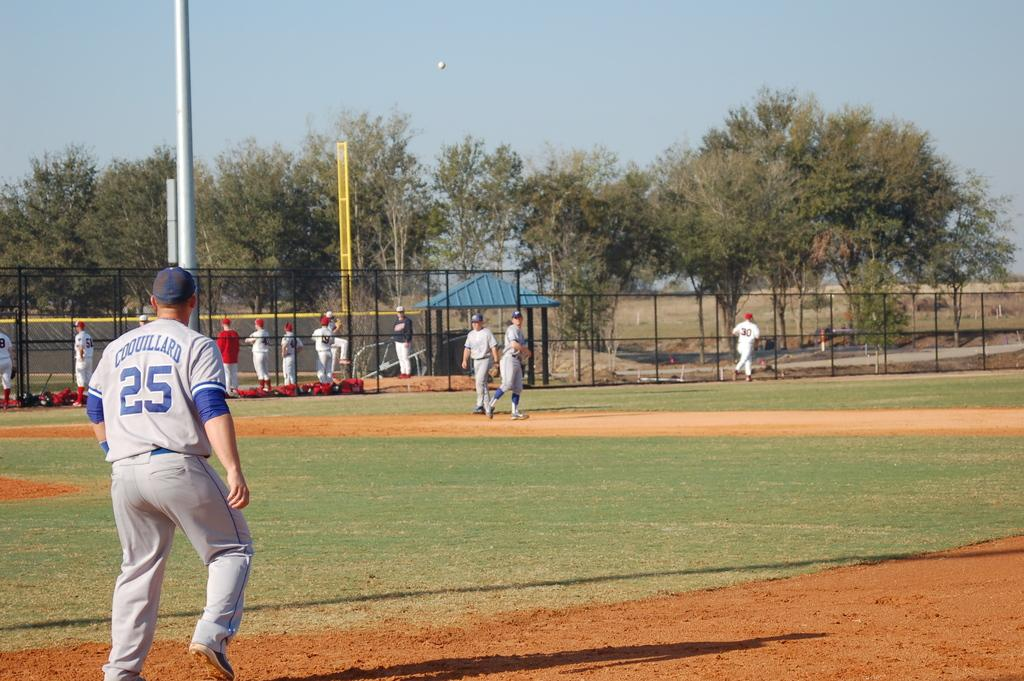<image>
Write a terse but informative summary of the picture. A baseball player on the field with the number 25 on his jersey. 